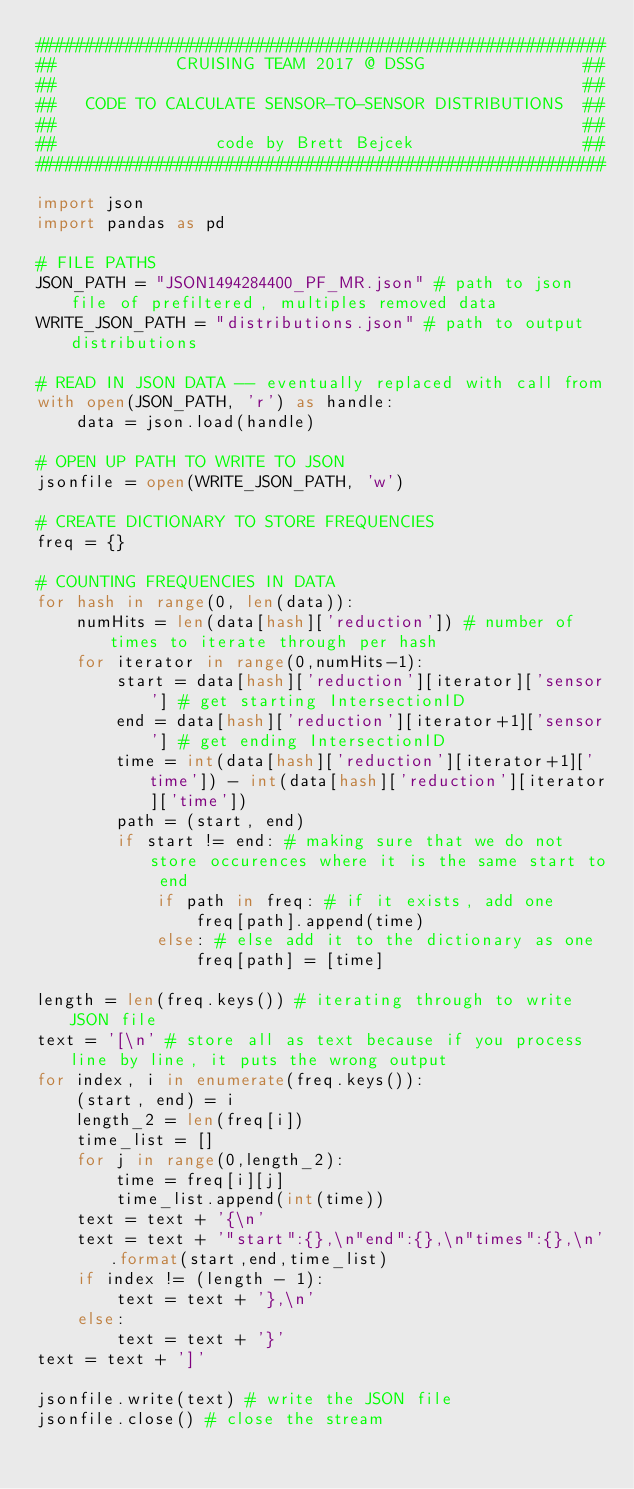<code> <loc_0><loc_0><loc_500><loc_500><_Python_>#########################################################
##            CRUISING TEAM 2017 @ DSSG                ##
##                                                     ##
##   CODE TO CALCULATE SENSOR-TO-SENSOR DISTRIBUTIONS  ##
##                                                     ##
##                code by Brett Bejcek                 ##
#########################################################

import json
import pandas as pd

# FILE PATHS
JSON_PATH = "JSON1494284400_PF_MR.json" # path to json file of prefiltered, multiples removed data
WRITE_JSON_PATH = "distributions.json" # path to output distributions

# READ IN JSON DATA -- eventually replaced with call from
with open(JSON_PATH, 'r') as handle:
    data = json.load(handle)

# OPEN UP PATH TO WRITE TO JSON
jsonfile = open(WRITE_JSON_PATH, 'w')

# CREATE DICTIONARY TO STORE FREQUENCIES
freq = {}

# COUNTING FREQUENCIES IN DATA
for hash in range(0, len(data)):
    numHits = len(data[hash]['reduction']) # number of times to iterate through per hash
    for iterator in range(0,numHits-1):
        start = data[hash]['reduction'][iterator]['sensor'] # get starting IntersectionID
        end = data[hash]['reduction'][iterator+1]['sensor'] # get ending IntersectionID
        time = int(data[hash]['reduction'][iterator+1]['time']) - int(data[hash]['reduction'][iterator]['time'])
        path = (start, end)
        if start != end: # making sure that we do not store occurences where it is the same start to end
            if path in freq: # if it exists, add one
                freq[path].append(time)
            else: # else add it to the dictionary as one
                freq[path] = [time]

length = len(freq.keys()) # iterating through to write JSON file
text = '[\n' # store all as text because if you process line by line, it puts the wrong output
for index, i in enumerate(freq.keys()):
    (start, end) = i
    length_2 = len(freq[i])
    time_list = []
    for j in range(0,length_2):
        time = freq[i][j]
        time_list.append(int(time))
    text = text + '{\n'
    text = text + '"start":{},\n"end":{},\n"times":{},\n'.format(start,end,time_list)
    if index != (length - 1):
        text = text + '},\n'
    else:
        text = text + '}'
text = text + ']'

jsonfile.write(text) # write the JSON file
jsonfile.close() # close the stream
</code> 